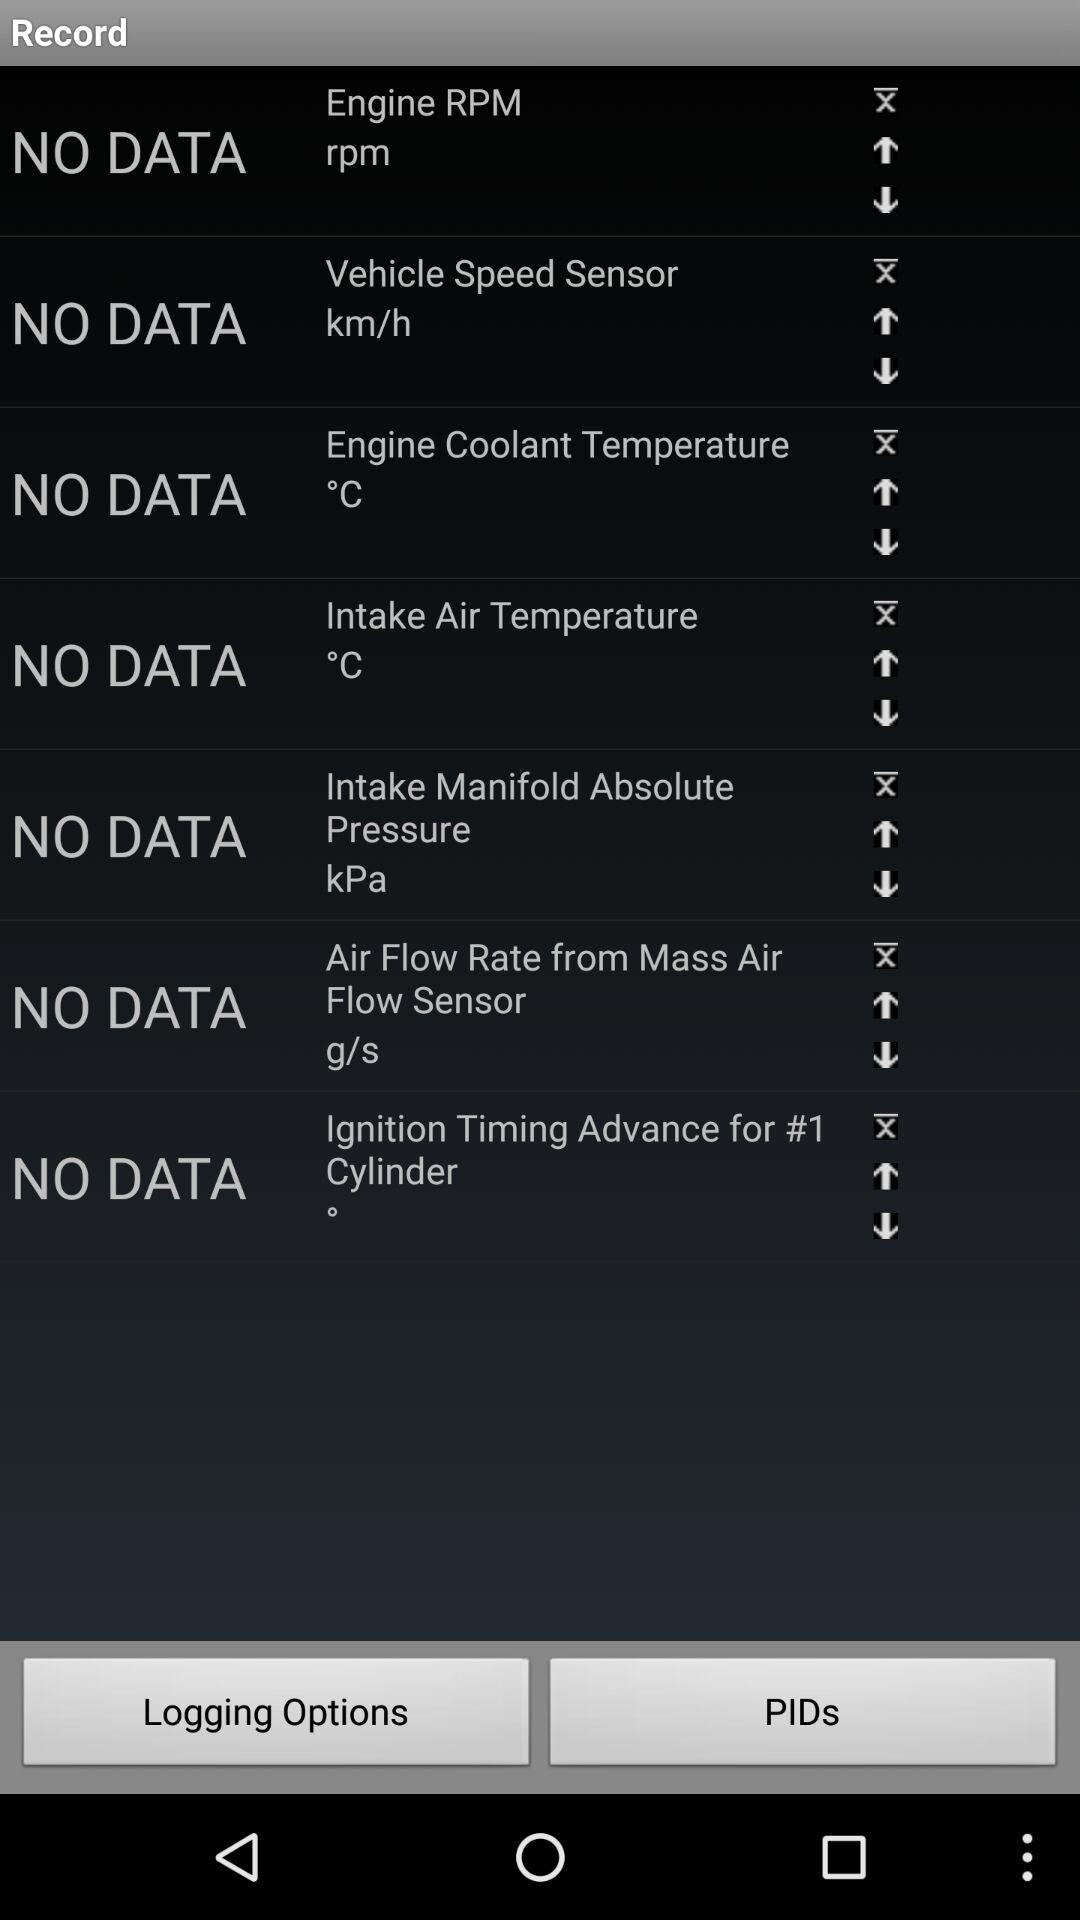What is the unit of speed? The units of speed are rpm and km/h. 